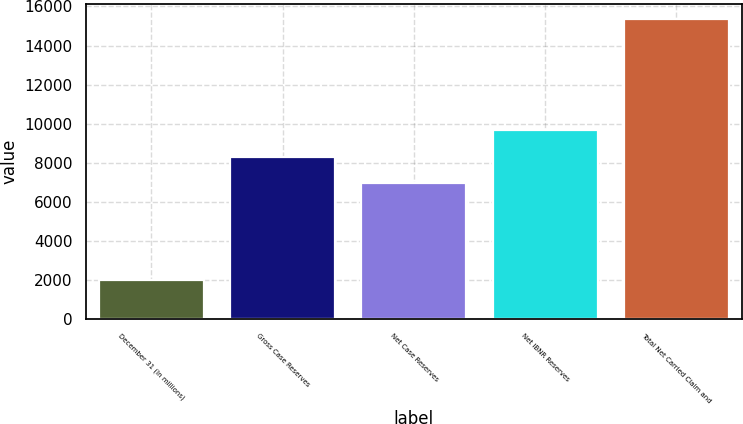Convert chart to OTSL. <chart><loc_0><loc_0><loc_500><loc_500><bar_chart><fcel>December 31 (In millions)<fcel>Gross Case Reserves<fcel>Net Case Reserves<fcel>Net IBNR Reserves<fcel>Total Net Carried Claim and<nl><fcel>2015<fcel>8326.8<fcel>6992<fcel>9661.6<fcel>15363<nl></chart> 